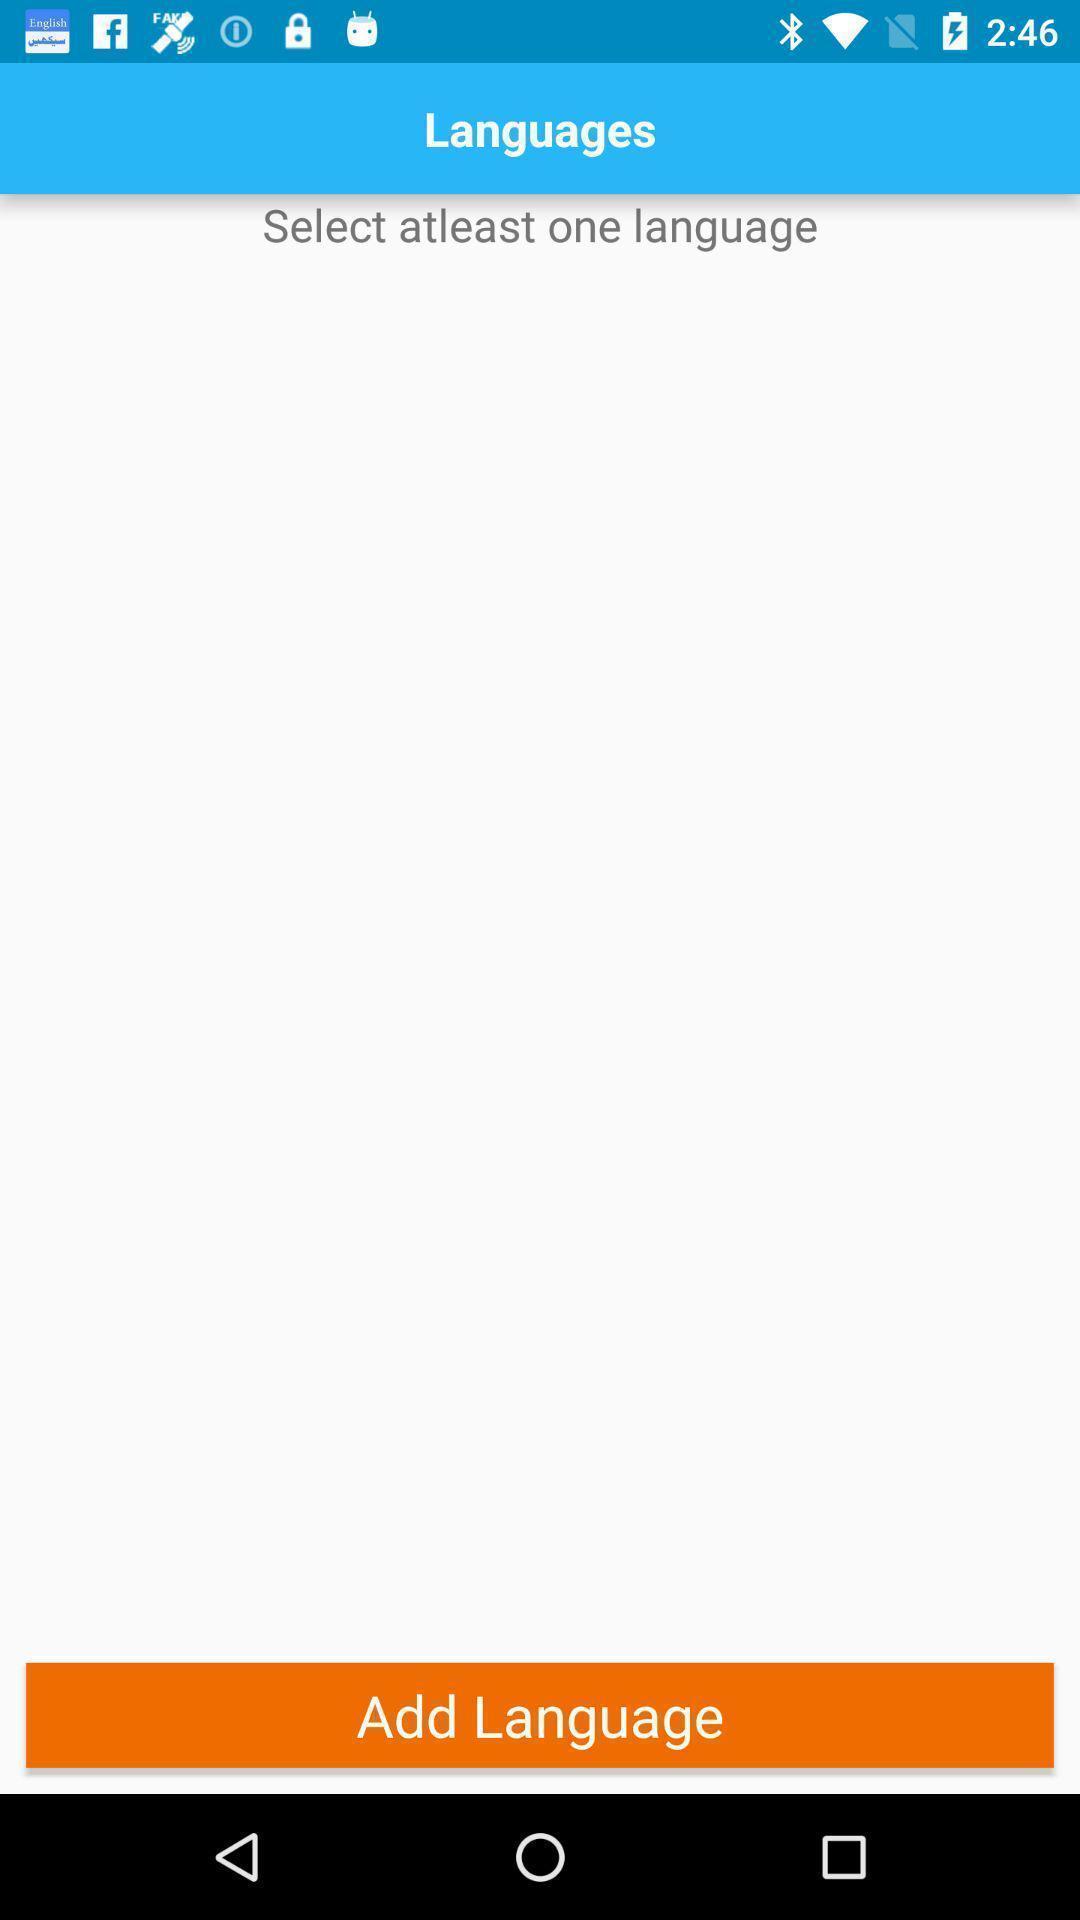Explain the elements present in this screenshot. Screen shows to select language. 